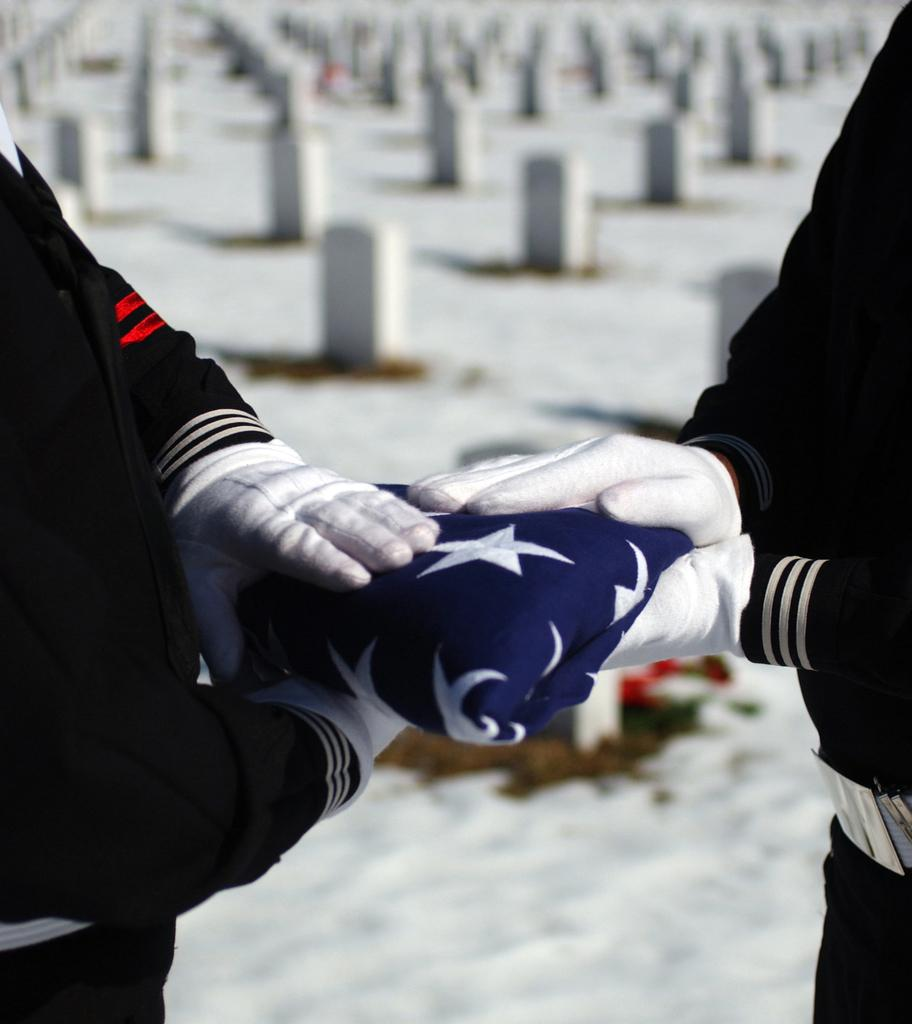How many people are in the image? There are two persons in the image. What are the two persons holding? The two persons are holding a cloth. What can be seen in the background of the image? There are small pillars in the background of the image. What type of drink is being served in the image? There is no drink present in the image; the two persons are holding a cloth. Can you tell me how many toes are visible on the persons in the image? The image does not show the persons' toes, so it cannot be determined from the image. 